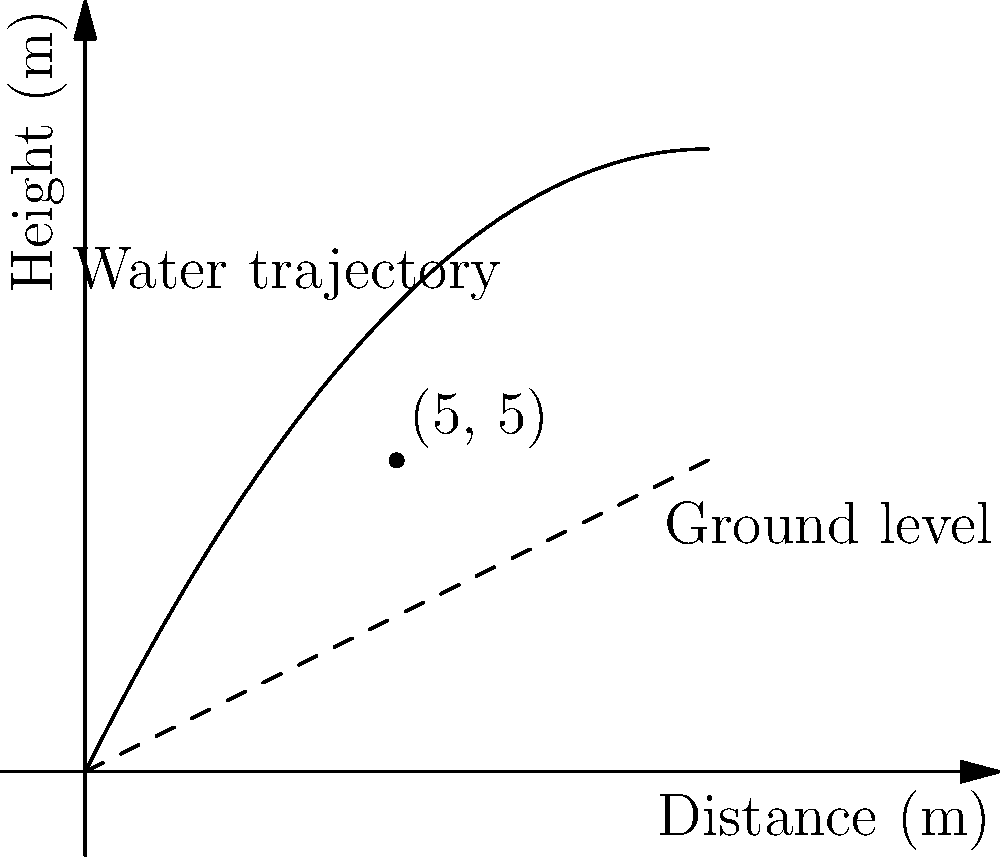A rotating sprinkler system is used to irrigate a circular field. The trajectory of the water can be modeled by the function $h(x) = -0.1x^2 + 2x$, where $h$ is the height in meters and $x$ is the horizontal distance from the sprinkler in meters. If the ground slopes upward at an angle such that its height can be described by the function $g(x) = 0.5x$, at what horizontal distance from the sprinkler does the water hit the ground? To find where the water hits the ground, we need to find the intersection point of the water trajectory function and the ground slope function. This is where $h(x) = g(x)$.

Step 1: Set up the equation
$-0.1x^2 + 2x = 0.5x$

Step 2: Rearrange the equation
$-0.1x^2 + 1.5x = 0$

Step 3: Factor out the common factor
$x(-0.1x + 1.5) = 0$

Step 4: Solve for x
Either $x = 0$ or $-0.1x + 1.5 = 0$
For the second equation: $x = 15$

Step 5: Check which solution makes sense in the context
$x = 0$ is where the sprinkler is located, so the water doesn't hit the ground there.
$x = 15$ is the point where the water trajectory intersects the sloping ground.

Therefore, the water hits the ground at a horizontal distance of 15 meters from the sprinkler.
Answer: 15 meters 